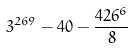<formula> <loc_0><loc_0><loc_500><loc_500>3 ^ { 2 6 9 } - 4 0 - \frac { 4 2 6 ^ { 6 } } { 8 }</formula> 